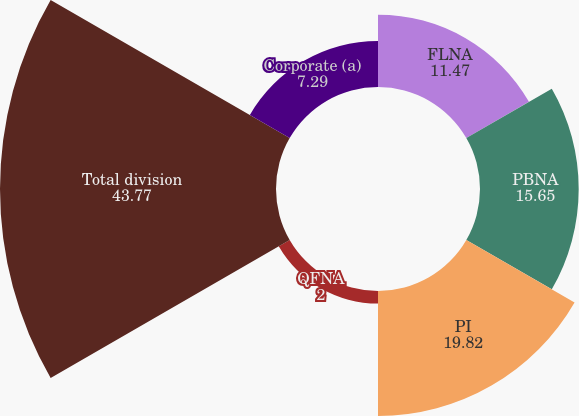Convert chart. <chart><loc_0><loc_0><loc_500><loc_500><pie_chart><fcel>FLNA<fcel>PBNA<fcel>PI<fcel>QFNA<fcel>Total division<fcel>Corporate (a)<nl><fcel>11.47%<fcel>15.65%<fcel>19.82%<fcel>2.0%<fcel>43.77%<fcel>7.29%<nl></chart> 